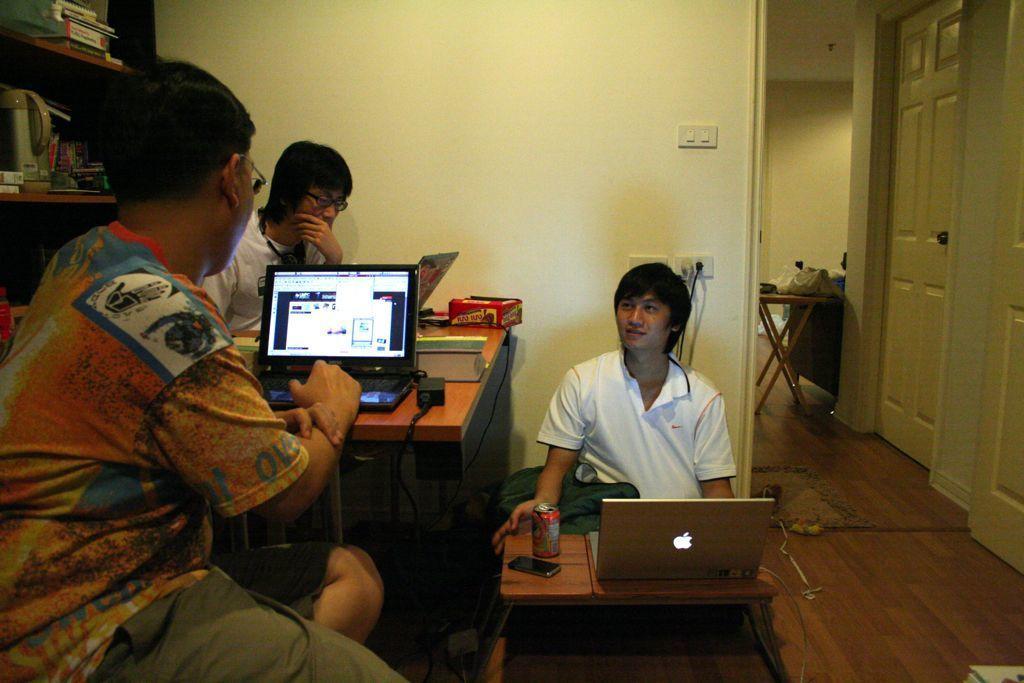Describe this image in one or two sentences. This picture is taken in the room,There are some people sitting on the chairs, There is a table in yellow color, on that table there is a laptop,In the middle there is a small table on that table there is a laptop and a person sitting on the ground, On the right side of the image there are two doors of cream color, In the background there is a wall of white color. 